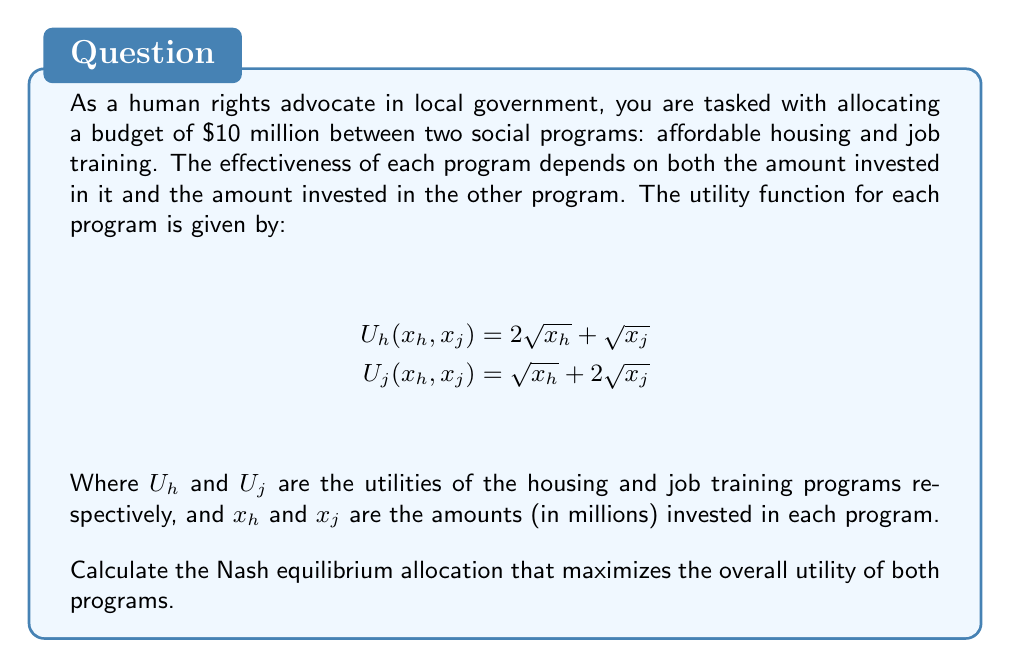Can you solve this math problem? To find the Nash equilibrium, we need to determine the allocation where neither program can unilaterally improve its utility by changing its allocation. We can do this by finding the maximum of each utility function with respect to its own variable, while treating the other variable as constant.

1. For the housing program:
   $$\frac{\partial U_h}{\partial x_h} = \frac{1}{\sqrt{x_h}} = 0$$
   This has no real solution, so we need to consider the boundary condition $x_h + x_j = 10$.

2. For the job training program:
   $$\frac{\partial U_j}{\partial x_j} = \frac{1}{\sqrt{x_j}} = 0$$
   This also has no real solution, so we again consider the boundary condition.

3. Given the boundary condition $x_h + x_j = 10$, we can substitute $x_j = 10 - x_h$ into both utility functions:

   $$U_h(x_h) = 2\sqrt{x_h} + \sqrt{10 - x_h}$$
   $$U_j(x_h) = \sqrt{x_h} + 2\sqrt{10 - x_h}$$

4. Now we can find the maximum of each function:

   For $U_h$: $$\frac{d U_h}{d x_h} = \frac{1}{\sqrt{x_h}} - \frac{1}{2\sqrt{10 - x_h}} = 0$$

   For $U_j$: $$\frac{d U_j}{d x_h} = \frac{1}{2\sqrt{x_h}} - \frac{1}{\sqrt{10 - x_h}} = 0$$

5. Solving these equations:

   For $U_h$: $\sqrt{10 - x_h} = 2\sqrt{x_h}$, which gives $x_h = \frac{10}{5} = 2$

   For $U_j$: $\sqrt{10 - x_h} = \frac{1}{2}\sqrt{x_h}$, which gives $x_h = \frac{40}{5} = 8$

6. The Nash equilibrium occurs where these two allocations intersect. Since they don't intersect within the valid range (0 to 10), the equilibrium must be at one of the extreme points.

7. Calculating the total utility at each extreme point:

   At $x_h = 2, x_j = 8$:
   $$U_h + U_j = (2\sqrt{2} + 2\sqrt{8}) + (\sqrt{2} + 2\sqrt{8}) = 2\sqrt{2} + 3\sqrt{8} + \sqrt{2} \approx 11.94$$

   At $x_h = 8, x_j = 2$:
   $$U_h + U_j = (2\sqrt{8} + \sqrt{2}) + (\sqrt{8} + 2\sqrt{2}) = 3\sqrt{8} + 3\sqrt{2} \approx 12.73$$

8. The Nash equilibrium is the allocation that gives the higher total utility, which is $x_h = 8, x_j = 2$.
Answer: The Nash equilibrium allocation is $8 million for affordable housing and $2 million for job training, resulting in a total utility of approximately 12.73. 